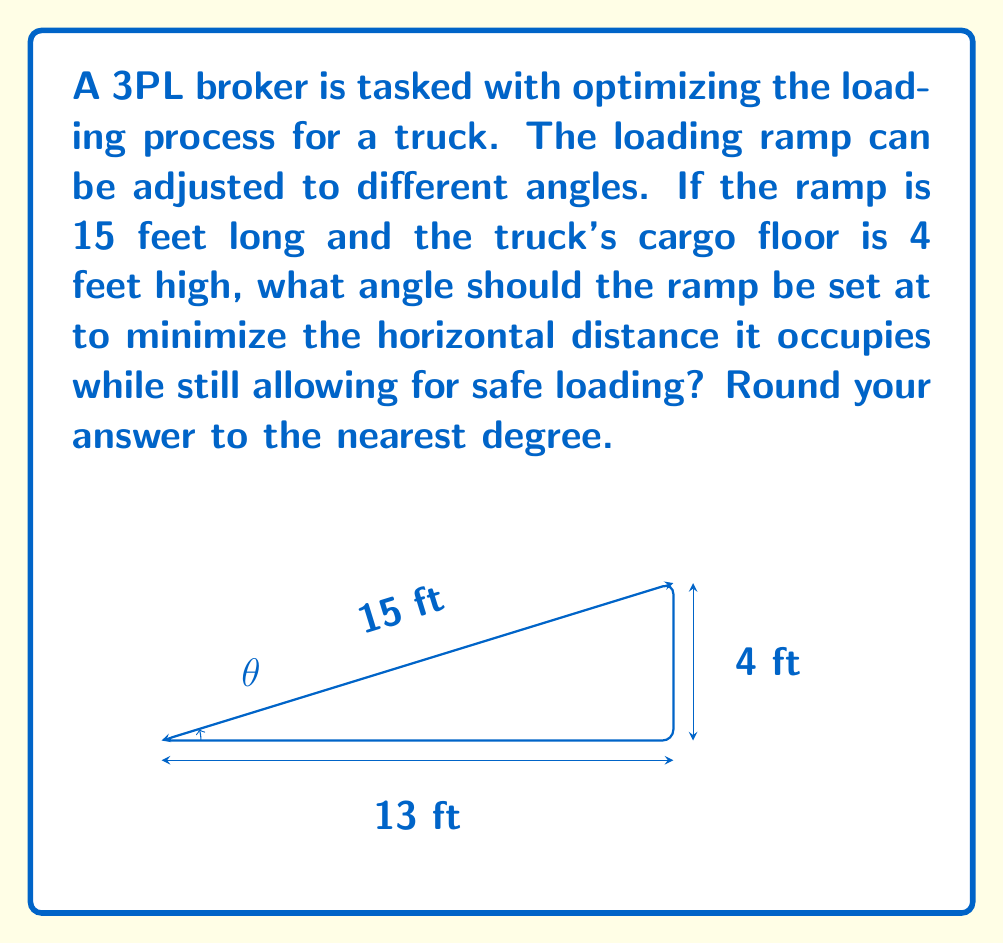Provide a solution to this math problem. To solve this problem, we can use trigonometry. Let's approach this step-by-step:

1) We're dealing with a right triangle where:
   - The hypotenuse is the ramp length (15 feet)
   - The opposite side is the truck's floor height (4 feet)
   - The adjacent side is the horizontal distance we want to minimize

2) We need to find the angle θ that maximizes the slope of the ramp while keeping it safe for loading.

3) We can use the sine function to relate the angle to the known sides:

   $$\sin θ = \frac{\text{opposite}}{\text{hypotenuse}} = \frac{4}{15}$$

4) To find θ, we take the inverse sine (arcsin):

   $$θ = \arcsin(\frac{4}{15})$$

5) Calculate this value:
   
   $$θ = \arcsin(0.2666...) ≈ 15.47°$$

6) Rounding to the nearest degree gives us 15°.

7) To verify, we can calculate the horizontal distance at this angle:
   
   $$\cos 15° = \frac{\text{adjacent}}{15}$$
   $$\text{adjacent} = 15 \cos 15° ≈ 14.48 \text{ feet}$$

This is indeed the minimum horizontal distance while maintaining a safe loading angle.
Answer: 15° 